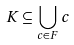<formula> <loc_0><loc_0><loc_500><loc_500>K \subseteq \bigcup _ { c \in F } c</formula> 